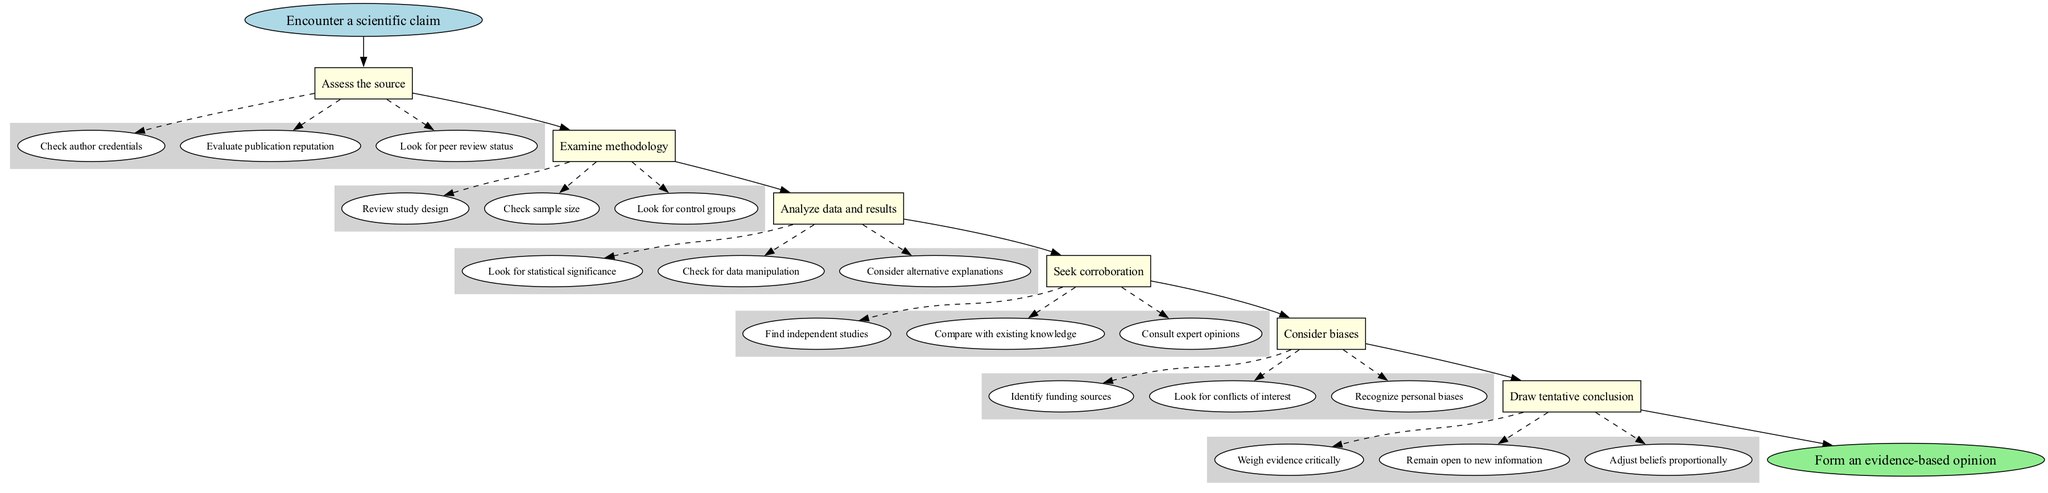What is the first step in the diagram? The first step in the diagram is indicated as the first node after the starting point, which is "Assess the source."
Answer: Assess the source How many steps are there in total? By counting the step nodes placed in the diagram, there are six distinct steps.
Answer: 6 What is the last node in the flow chart? The last node in the flow chart is connected to the last step and is labeled as the final outcome, which is "Form an evidence-based opinion."
Answer: Form an evidence-based opinion Which step directly follows "Examine methodology"? By tracing the sequence of steps in the flow chart, "Analyze data and results" comes immediately after "Examine methodology."
Answer: Analyze data and results What do you need to check when assessing the source? The details under "Assess the source" specify that you should check "author credentials," "publication reputation," and "peer review status."
Answer: author credentials, publication reputation, peer review status How does the flow of steps progress from the start to the end? The flow progresses from the start point to the first step "Assess the source," followed by "Examine methodology," then to "Analyze data and results," which leads to "Seek corroboration," followed by "Consider biases," and finally ends with "Draw tentative conclusion" before reaching "Form an evidence-based opinion."
Answer: Assess the source to Examine methodology to Analyze data and results to Seek corroboration to Consider biases to Draw tentative conclusion to Form an evidence-based opinion What is one reason to seek corroboration? One reason detailed in the step "Seek corroboration" is to find independent studies that support the discussed scientific claim.
Answer: Find independent studies What considerations are taken into account when drawing a conclusion? The details of "Draw tentative conclusion" emphasize weighing evidence critically, remaining open to new information, and adjusting beliefs proportionally.
Answer: Weigh evidence critically, remain open to new information, adjust beliefs proportionally 